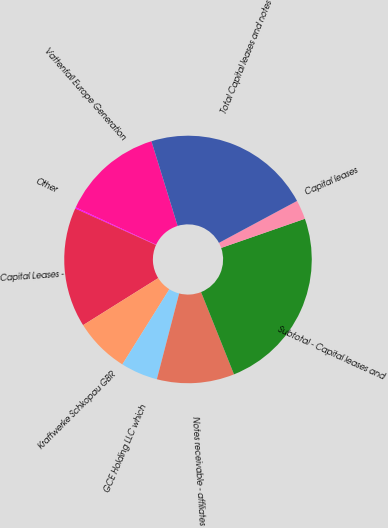<chart> <loc_0><loc_0><loc_500><loc_500><pie_chart><fcel>Vattenfall Europe Generation<fcel>Other<fcel>Capital Leases -<fcel>Kraftwerke Schkopau GBR<fcel>GCE Holding LLC which<fcel>Notes receivable - affiliates<fcel>Subtotal - Capital leases and<fcel>Capital leases<fcel>Total Capital leases and notes<nl><fcel>13.31%<fcel>0.17%<fcel>15.65%<fcel>7.2%<fcel>4.85%<fcel>10.11%<fcel>24.27%<fcel>2.51%<fcel>21.93%<nl></chart> 